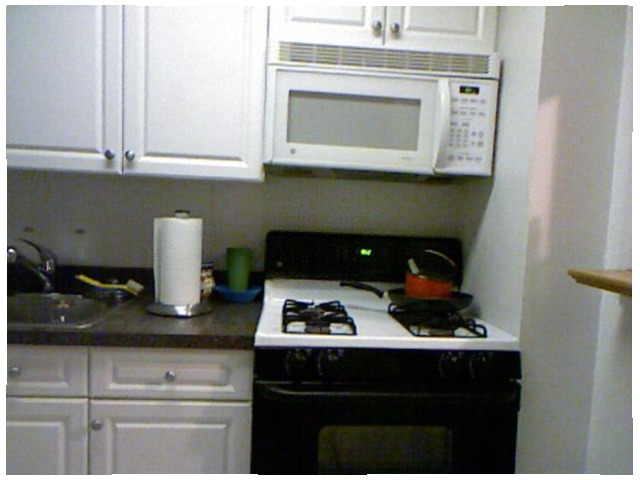<image>
Can you confirm if the cup is on the counter? Yes. Looking at the image, I can see the cup is positioned on top of the counter, with the counter providing support. Is there a light in the stove? Yes. The light is contained within or inside the stove, showing a containment relationship. 